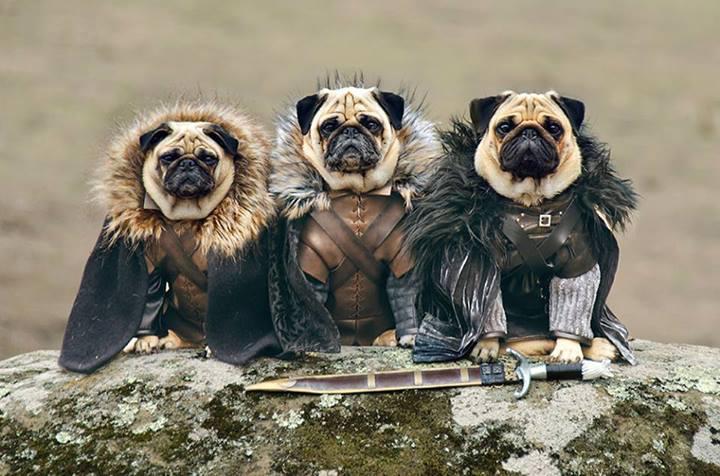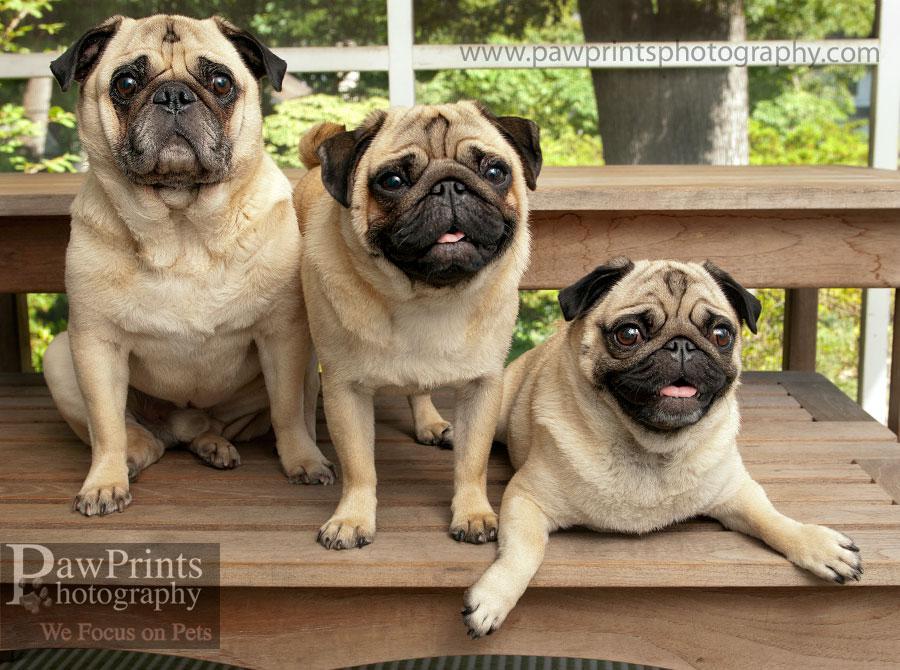The first image is the image on the left, the second image is the image on the right. Evaluate the accuracy of this statement regarding the images: "An image features three pugs in costumes that include fur trimming.". Is it true? Answer yes or no. Yes. The first image is the image on the left, the second image is the image on the right. Evaluate the accuracy of this statement regarding the images: "There are exactly three dogs in the right image.". Is it true? Answer yes or no. Yes. 